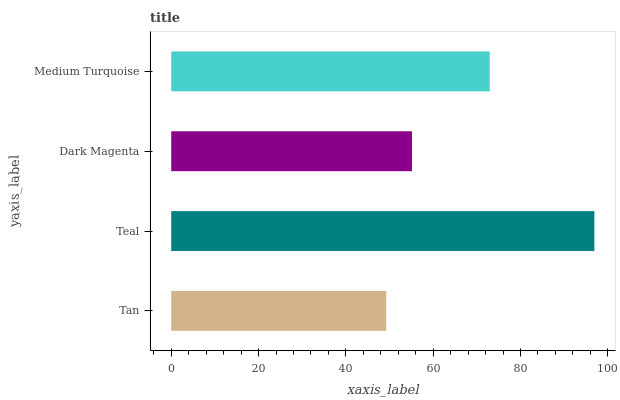Is Tan the minimum?
Answer yes or no. Yes. Is Teal the maximum?
Answer yes or no. Yes. Is Dark Magenta the minimum?
Answer yes or no. No. Is Dark Magenta the maximum?
Answer yes or no. No. Is Teal greater than Dark Magenta?
Answer yes or no. Yes. Is Dark Magenta less than Teal?
Answer yes or no. Yes. Is Dark Magenta greater than Teal?
Answer yes or no. No. Is Teal less than Dark Magenta?
Answer yes or no. No. Is Medium Turquoise the high median?
Answer yes or no. Yes. Is Dark Magenta the low median?
Answer yes or no. Yes. Is Teal the high median?
Answer yes or no. No. Is Teal the low median?
Answer yes or no. No. 